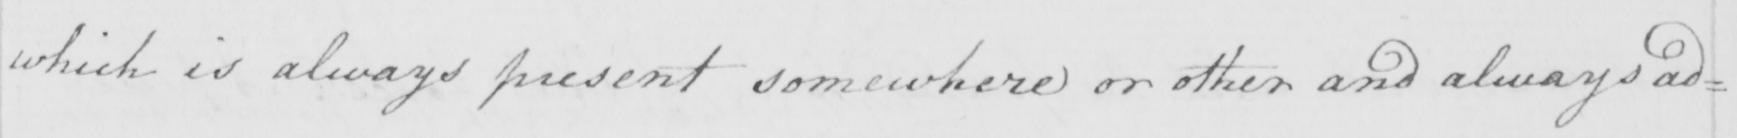What does this handwritten line say? which is always present somewhere or other and always ad= 